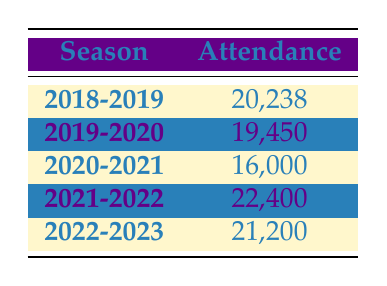What was the highest attendance figure over the last five seasons? The table lists the attendance figures for each season. Looking through the figures, 22,400 in the 2021-2022 season is the highest attendance.
Answer: 22,400 What was the attendance for the 2019-2020 season? The table directly shows that the attendance for the 2019-2020 season is 19,450.
Answer: 19,450 What is the attendance difference between the seasons with the highest and lowest attendance? The highest attendance is 22,400 (2021-2022 season), and the lowest is 16,000 (2020-2021 season). The difference is 22,400 - 16,000 = 6,400.
Answer: 6,400 Did the attendance increase from the 2020-2021 season to the 2021-2022 season? Comparing the attendance figures, 16,000 (2020-2021) is less than 22,400 (2021-2022). Therefore, attendance did increase.
Answer: Yes What is the average attendance over the five seasons? To find the average attendance, sum all attendance values: 20,238 + 19,450 + 16,000 + 22,400 + 21,200 = 99,288. Now divide by 5 to get the average: 99,288 / 5 = 19,857.6.
Answer: 19,857.6 In which season did ACF Fiorentina see a drop in attendance compared to the previous season? Checking the attendance data: from the 2018-2019 season (20,238) to the 2019-2020 season (19,450) there was a drop. Also, from 2019-2020 (19,450) to 2020-2021 (16,000), there was another drop.
Answer: 2019-2020 and 2020-2021 What was the total attendance for the 2022-2023 season and the 2021-2022 season combined? The attendance for the 2021-2022 season is 22,400 and for the 2022-2023 season is 21,200. Adding them together gives 22,400 + 21,200 = 43,600.
Answer: 43,600 Was the attendance for the 2018-2019 season higher than 21,000? The attendance for the 2018-2019 season is 20,238, which is less than 21,000. Therefore, the statement is false.
Answer: No 